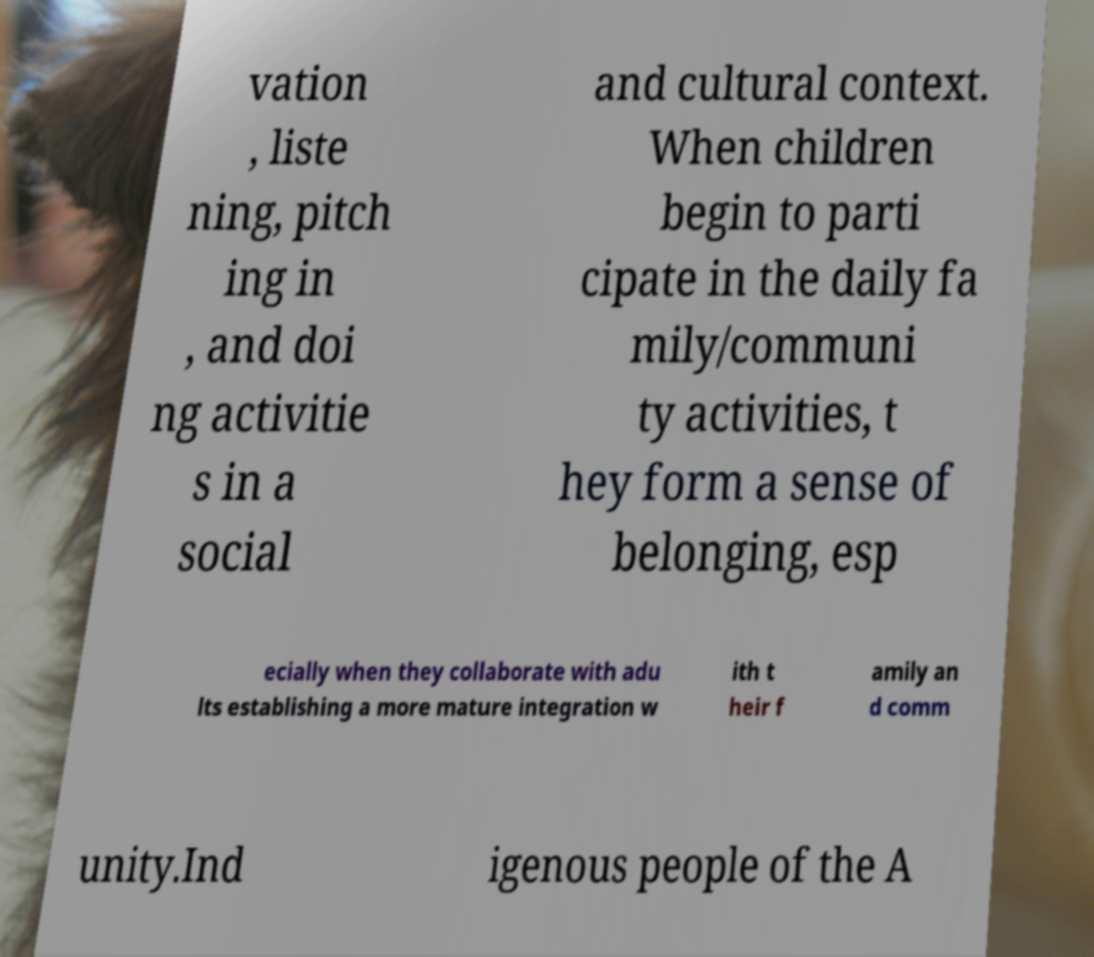Could you assist in decoding the text presented in this image and type it out clearly? vation , liste ning, pitch ing in , and doi ng activitie s in a social and cultural context. When children begin to parti cipate in the daily fa mily/communi ty activities, t hey form a sense of belonging, esp ecially when they collaborate with adu lts establishing a more mature integration w ith t heir f amily an d comm unity.Ind igenous people of the A 